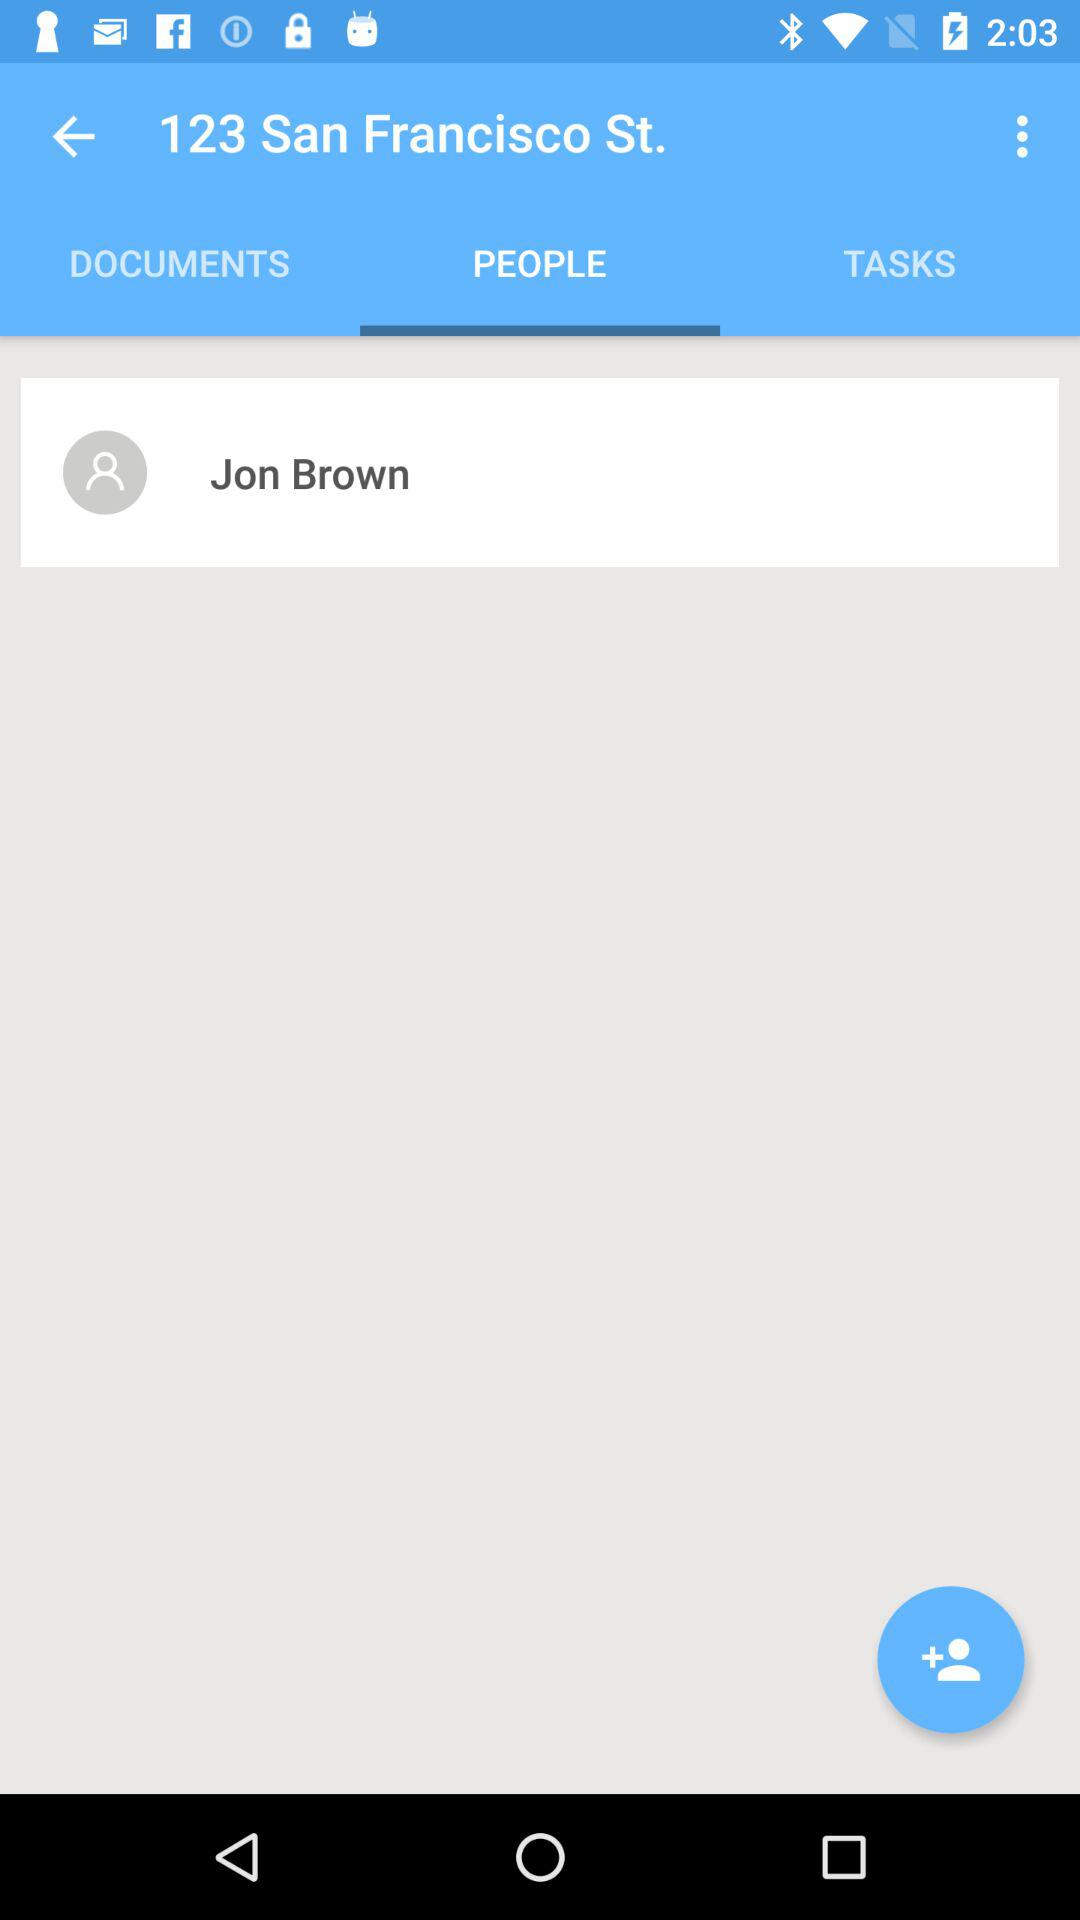What is the profile name? The profile name is Jon Brown. 